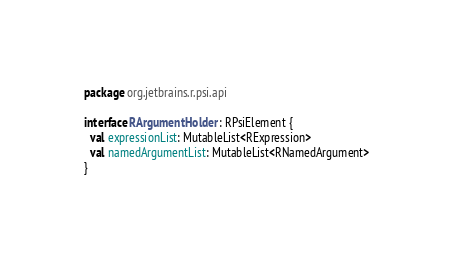<code> <loc_0><loc_0><loc_500><loc_500><_Kotlin_>package org.jetbrains.r.psi.api

interface RArgumentHolder : RPsiElement {
  val expressionList: MutableList<RExpression>
  val namedArgumentList: MutableList<RNamedArgument>
}</code> 